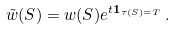Convert formula to latex. <formula><loc_0><loc_0><loc_500><loc_500>\tilde { w } ( S ) = w ( S ) e ^ { t \mathbf 1 _ { \tau ( S ) = T } } \, .</formula> 